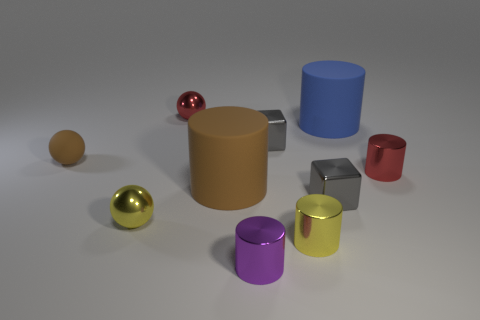Subtract 3 cylinders. How many cylinders are left? 2 Subtract all metallic spheres. How many spheres are left? 1 Subtract all purple cylinders. How many cylinders are left? 4 Subtract all yellow cylinders. Subtract all yellow spheres. How many cylinders are left? 4 Subtract all balls. How many objects are left? 7 Subtract all red shiny spheres. Subtract all gray metallic blocks. How many objects are left? 7 Add 3 red metallic spheres. How many red metallic spheres are left? 4 Add 7 tiny gray metal things. How many tiny gray metal things exist? 9 Subtract 0 green cylinders. How many objects are left? 10 